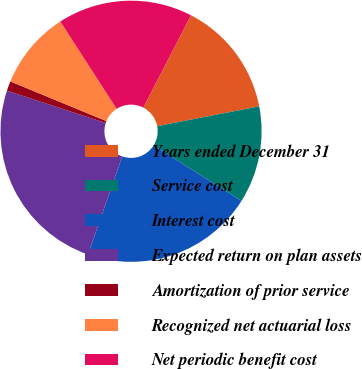Convert chart to OTSL. <chart><loc_0><loc_0><loc_500><loc_500><pie_chart><fcel>Years ended December 31<fcel>Service cost<fcel>Interest cost<fcel>Expected return on plan assets<fcel>Amortization of prior service<fcel>Recognized net actuarial loss<fcel>Net periodic benefit cost<nl><fcel>14.35%<fcel>12.01%<fcel>21.4%<fcel>24.68%<fcel>1.2%<fcel>9.66%<fcel>16.7%<nl></chart> 